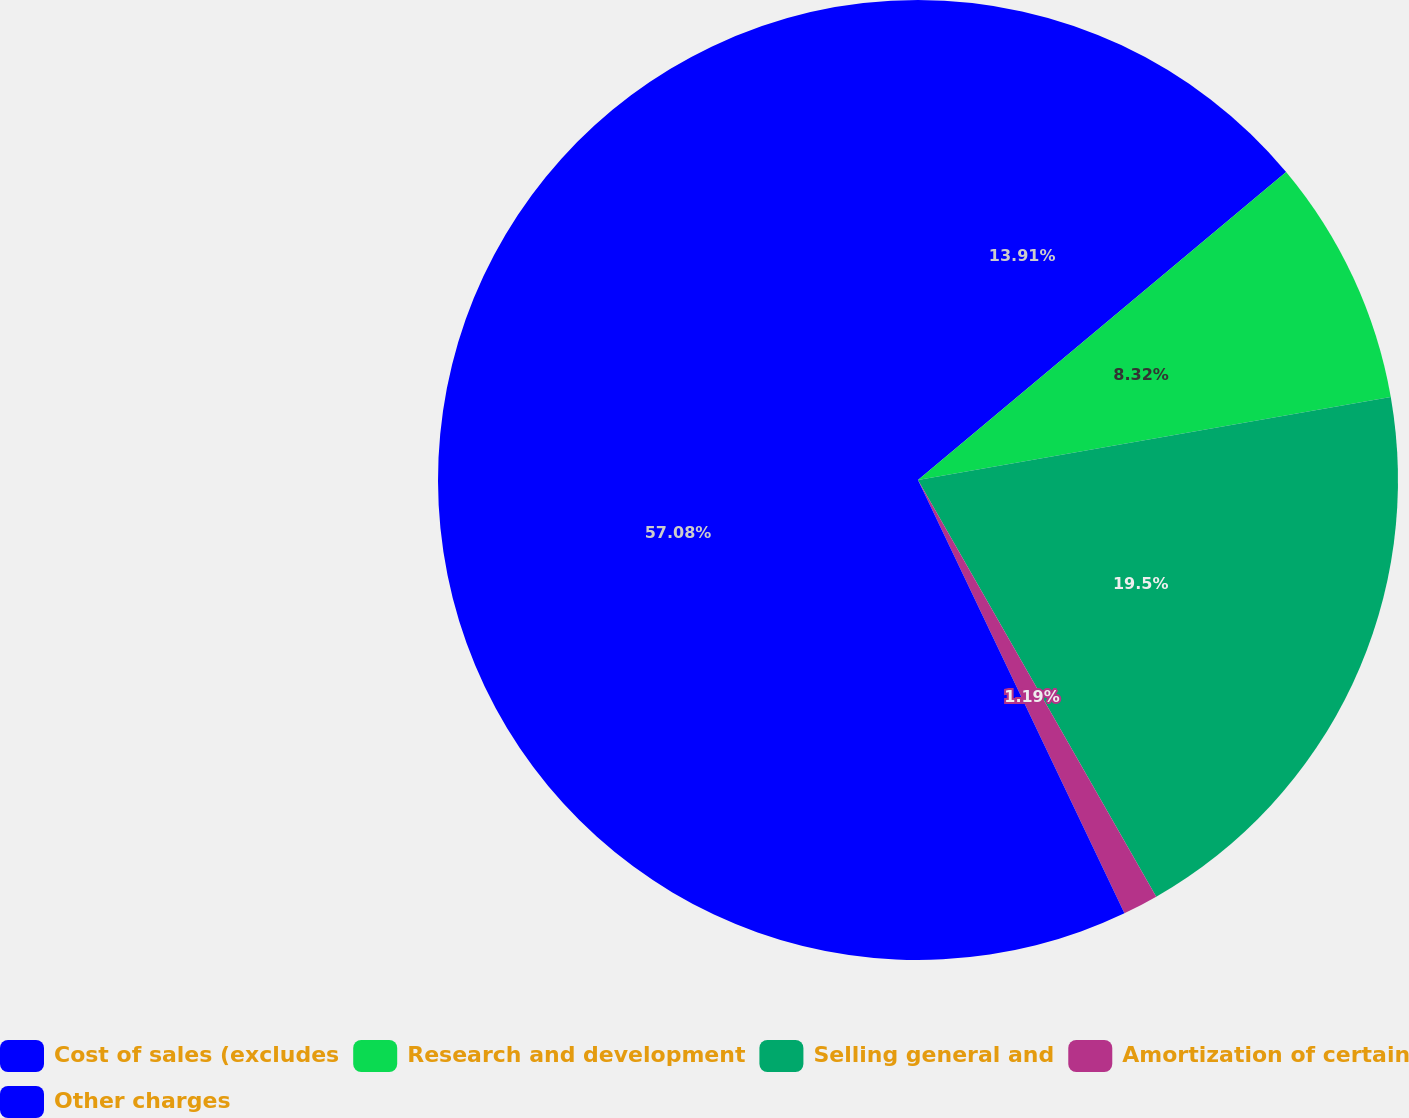Convert chart to OTSL. <chart><loc_0><loc_0><loc_500><loc_500><pie_chart><fcel>Cost of sales (excludes<fcel>Research and development<fcel>Selling general and<fcel>Amortization of certain<fcel>Other charges<nl><fcel>13.91%<fcel>8.32%<fcel>19.5%<fcel>1.19%<fcel>57.07%<nl></chart> 